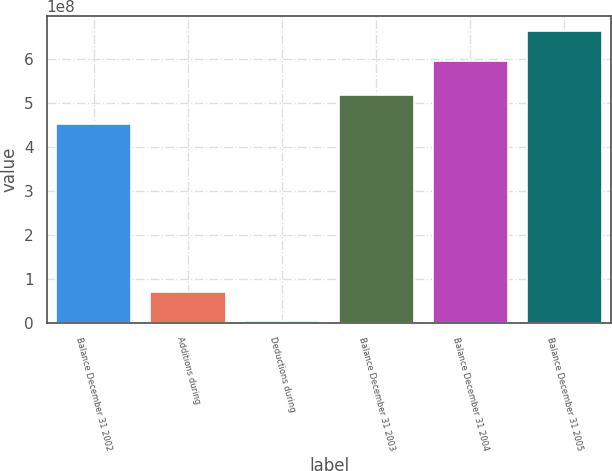<chart> <loc_0><loc_0><loc_500><loc_500><bar_chart><fcel>Balance December 31 2002<fcel>Additions during<fcel>Deductions during<fcel>Balance December 31 2003<fcel>Balance December 31 2004<fcel>Balance December 31 2005<nl><fcel>4.50697e+08<fcel>7.05555e+07<fcel>4.645e+06<fcel>5.16608e+08<fcel>5.95338e+08<fcel>6.6375e+08<nl></chart> 